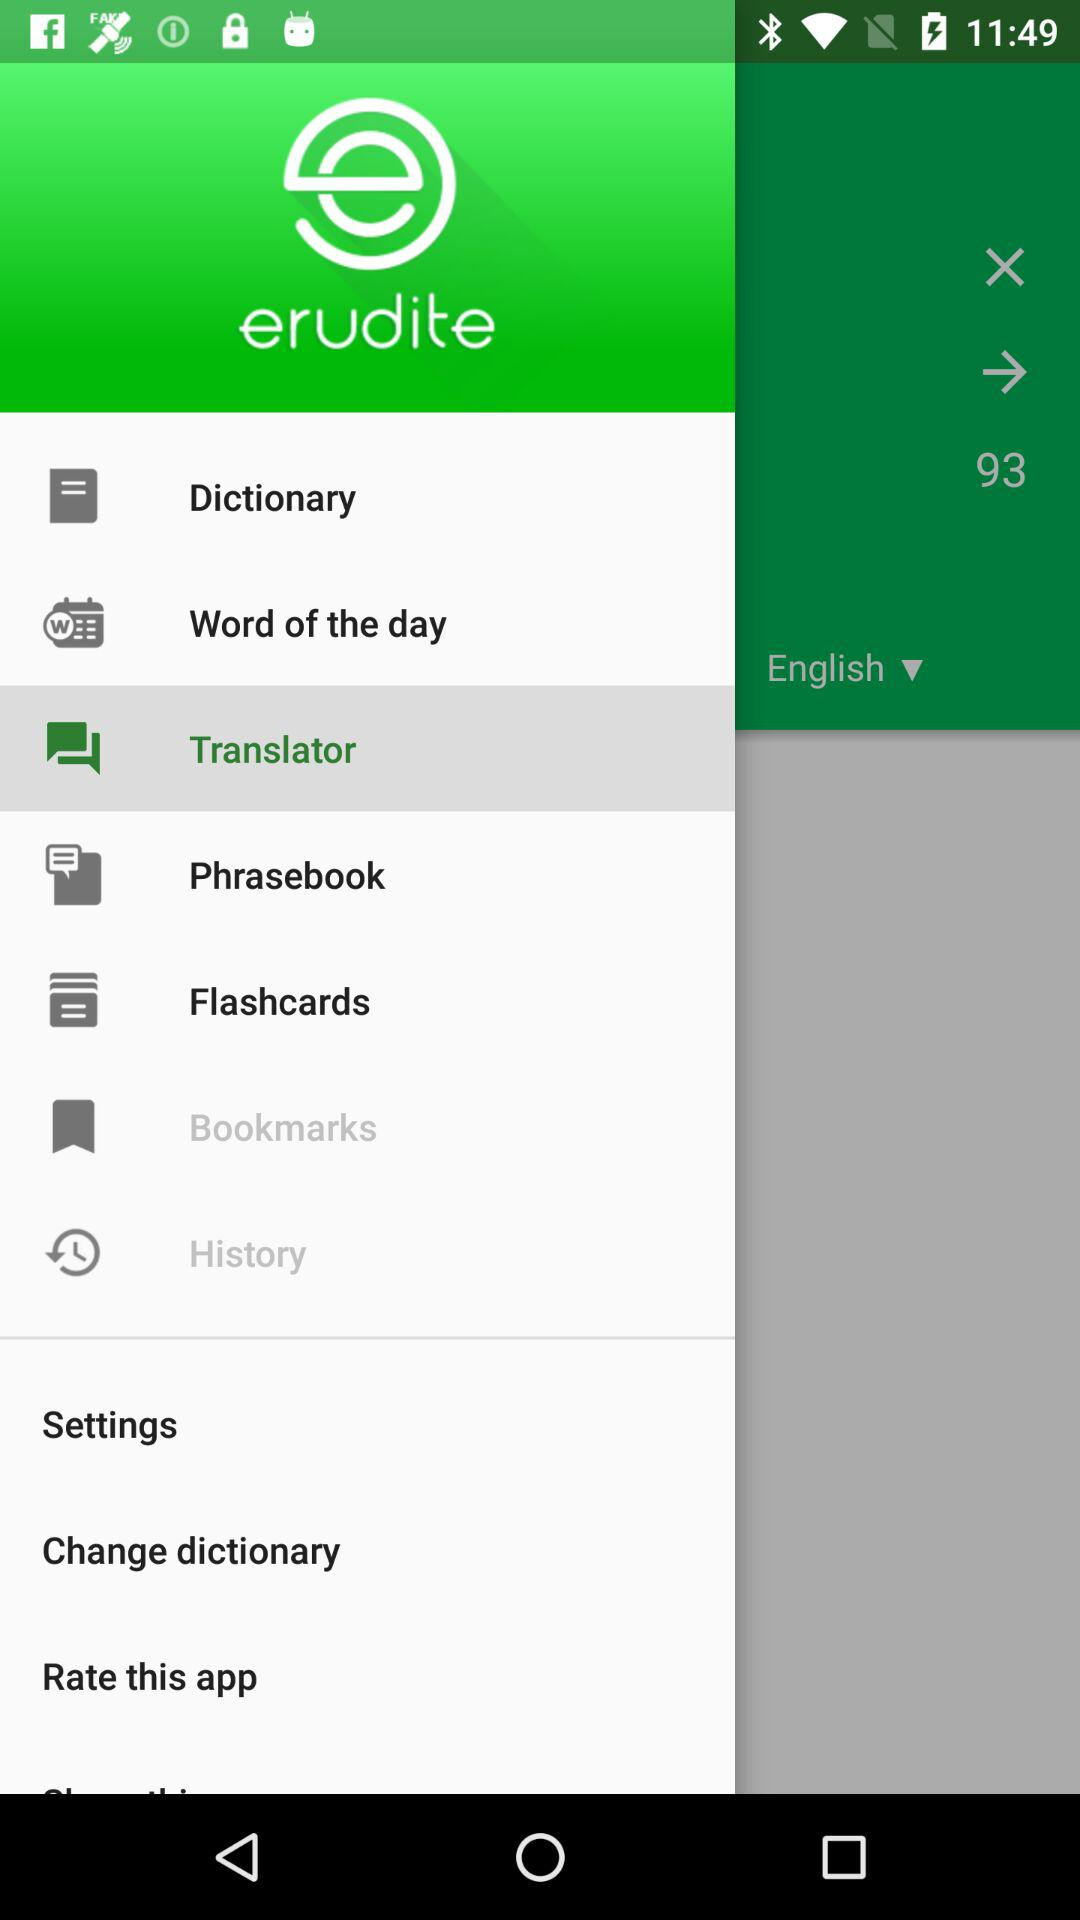Which option is selected? The selected option is "English". 